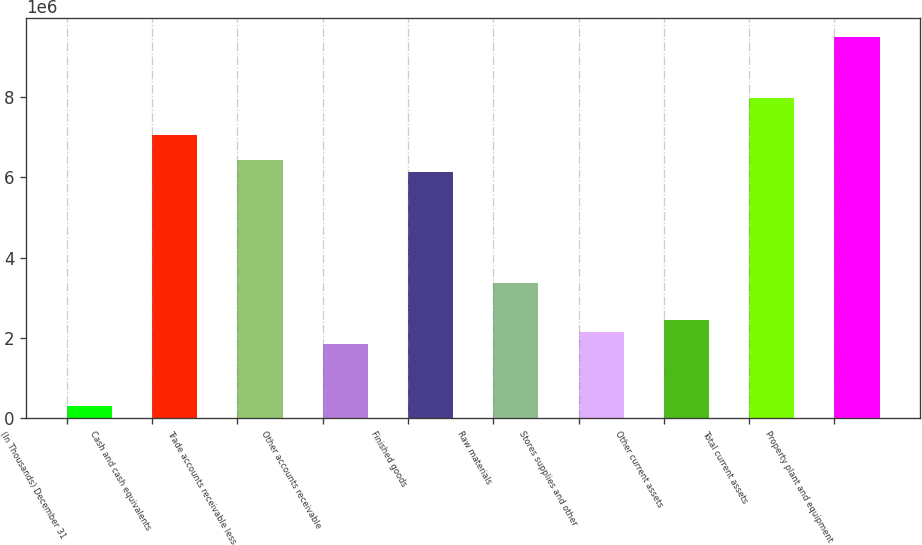Convert chart. <chart><loc_0><loc_0><loc_500><loc_500><bar_chart><fcel>(In Thousands) December 31<fcel>Cash and cash equivalents<fcel>Trade accounts receivable less<fcel>Other accounts receivable<fcel>Finished goods<fcel>Raw materials<fcel>Stores supplies and other<fcel>Other current assets<fcel>Total current assets<fcel>Property plant and equipment<nl><fcel>307632<fcel>7.0554e+06<fcel>6.44196e+06<fcel>1.84122e+06<fcel>6.13525e+06<fcel>3.3748e+06<fcel>2.14793e+06<fcel>2.45465e+06<fcel>7.97554e+06<fcel>9.50913e+06<nl></chart> 